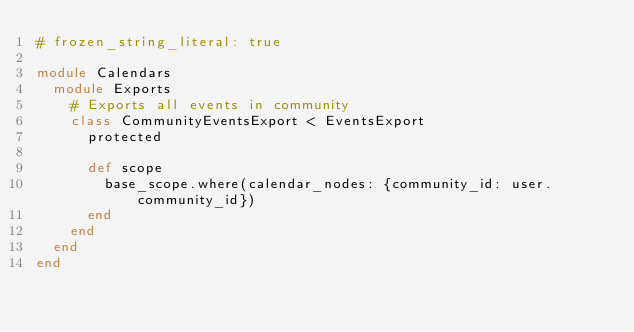<code> <loc_0><loc_0><loc_500><loc_500><_Ruby_># frozen_string_literal: true

module Calendars
  module Exports
    # Exports all events in community
    class CommunityEventsExport < EventsExport
      protected

      def scope
        base_scope.where(calendar_nodes: {community_id: user.community_id})
      end
    end
  end
end
</code> 